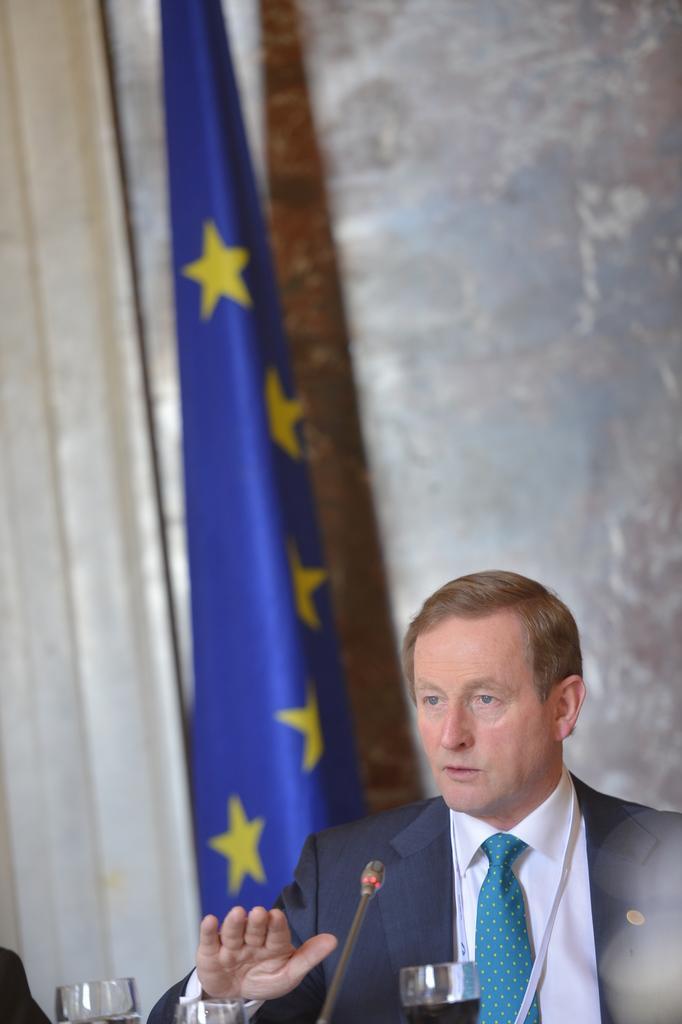Can you describe this image briefly? Here we can see a man and there glasses with liquid and microphone. In the background there is a flag,curtain and a wall. 